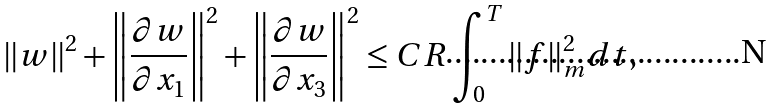<formula> <loc_0><loc_0><loc_500><loc_500>\left \| w \right \| ^ { 2 } + \left \| \frac { \partial w } { \partial x _ { 1 } } \right \| ^ { 2 } + \left \| \frac { \partial w } { \partial x _ { 3 } } \right \| ^ { 2 } \leq C R \int _ { 0 } ^ { T } \| f \| _ { m } ^ { 2 } d t ,</formula> 